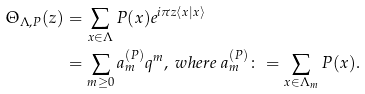<formula> <loc_0><loc_0><loc_500><loc_500>\Theta _ { \Lambda , P } ( z ) & = \sum _ { x \in \Lambda } P ( x ) e ^ { i \pi z \langle x | x \rangle } \\ & = \sum _ { m \geq 0 } a ^ { ( P ) } _ { m } q ^ { m } , \ w h e r e \ a ^ { ( P ) } _ { m } \colon = \sum _ { x \in \Lambda _ { m } } P ( x ) .</formula> 